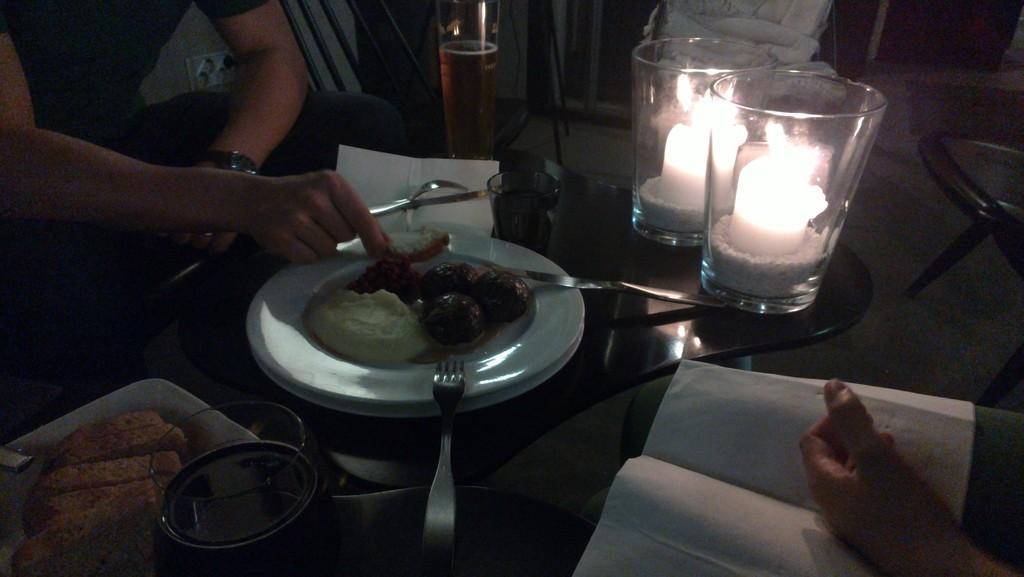How would you summarize this image in a sentence or two? This picture is of inside. On the right there is a person sitting. In the center there is a table on the top of which plate full of food, glass and two candles are placed. On the left there is a person holding a fork and sitting on the chair. In the background we can see the floor and the chair. 